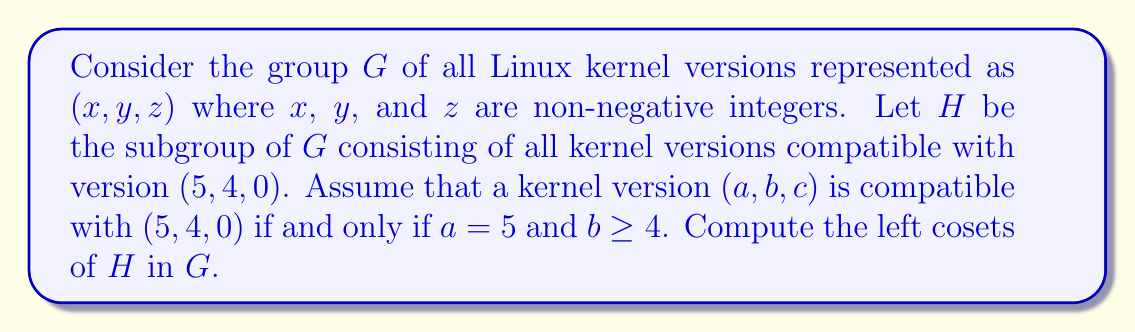Solve this math problem. To solve this problem, let's follow these steps:

1) First, let's define the group $G$ and subgroup $H$ formally:
   $G = \{(x, y, z) | x, y, z \in \mathbb{Z}_{\geq 0}\}$
   $H = \{(5, b, c) | b \geq 4, c \in \mathbb{Z}_{\geq 0}\}$

2) To find the left cosets of $H$ in $G$, we need to consider elements $g \in G$ and compute $gH$ for each distinct coset.

3) Let's consider an arbitrary element $g = (a, b, c) \in G$. The left coset $gH$ is:
   $gH = \{(a, b, c)(5, y, z) | y \geq 4, z \in \mathbb{Z}_{\geq 0}\}$
   $= \{(a, b, c) | c \in \mathbb{Z}_{\geq 0}\}$

4) We can see that the coset only depends on the first two components of $g$. This means that all elements with the same first two components will be in the same coset.

5) We can categorize the cosets as follows:
   - For $a < 5$: $(a, b, 0)H$ where $a < 5$ and $b \in \mathbb{Z}_{\geq 0}$
   - For $a = 5$ and $b < 4$: $(5, b, 0)H$ where $b < 4$
   - For $a = 5$ and $b \geq 4$: This is the subgroup $H$ itself
   - For $a > 5$: $(a, b, 0)H$ where $a > 5$ and $b \in \mathbb{Z}_{\geq 0}$

6) Each of these cosets is distinct from the others, and together they partition the group $G$.
Answer: The left cosets of $H$ in $G$ are:
$$\{(a, b, c)H | a < 5, b \in \mathbb{Z}_{\geq 0}\} \cup \{(5, 0, 0)H, (5, 1, 0)H, (5, 2, 0)H, (5, 3, 0)H\} \cup \{H\} \cup \{(a, b, c)H | a > 5, b \in \mathbb{Z}_{\geq 0}\}$$
where each coset $(a, b, c)H = \{(a, b, z) | z \in \mathbb{Z}_{\geq 0}\}$. 